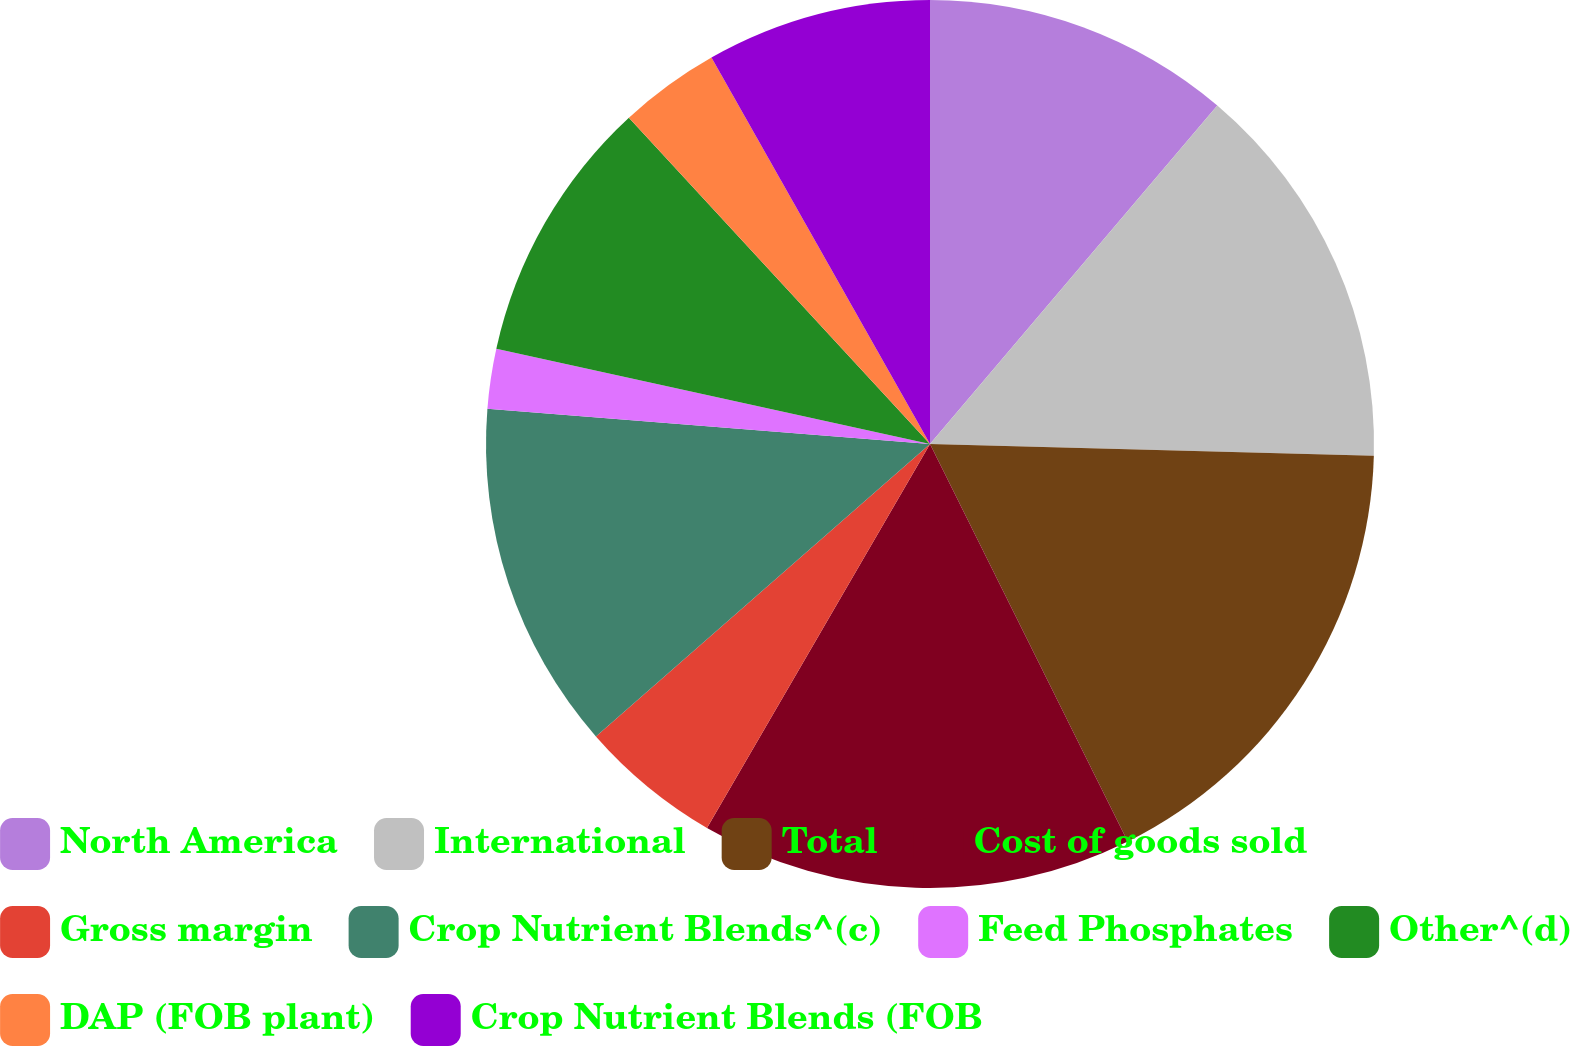Convert chart to OTSL. <chart><loc_0><loc_0><loc_500><loc_500><pie_chart><fcel>North America<fcel>International<fcel>Total<fcel>Cost of goods sold<fcel>Gross margin<fcel>Crop Nutrient Blends^(c)<fcel>Feed Phosphates<fcel>Other^(d)<fcel>DAP (FOB plant)<fcel>Crop Nutrient Blends (FOB<nl><fcel>11.2%<fcel>14.22%<fcel>17.23%<fcel>15.72%<fcel>5.18%<fcel>12.71%<fcel>2.17%<fcel>9.7%<fcel>3.67%<fcel>8.19%<nl></chart> 